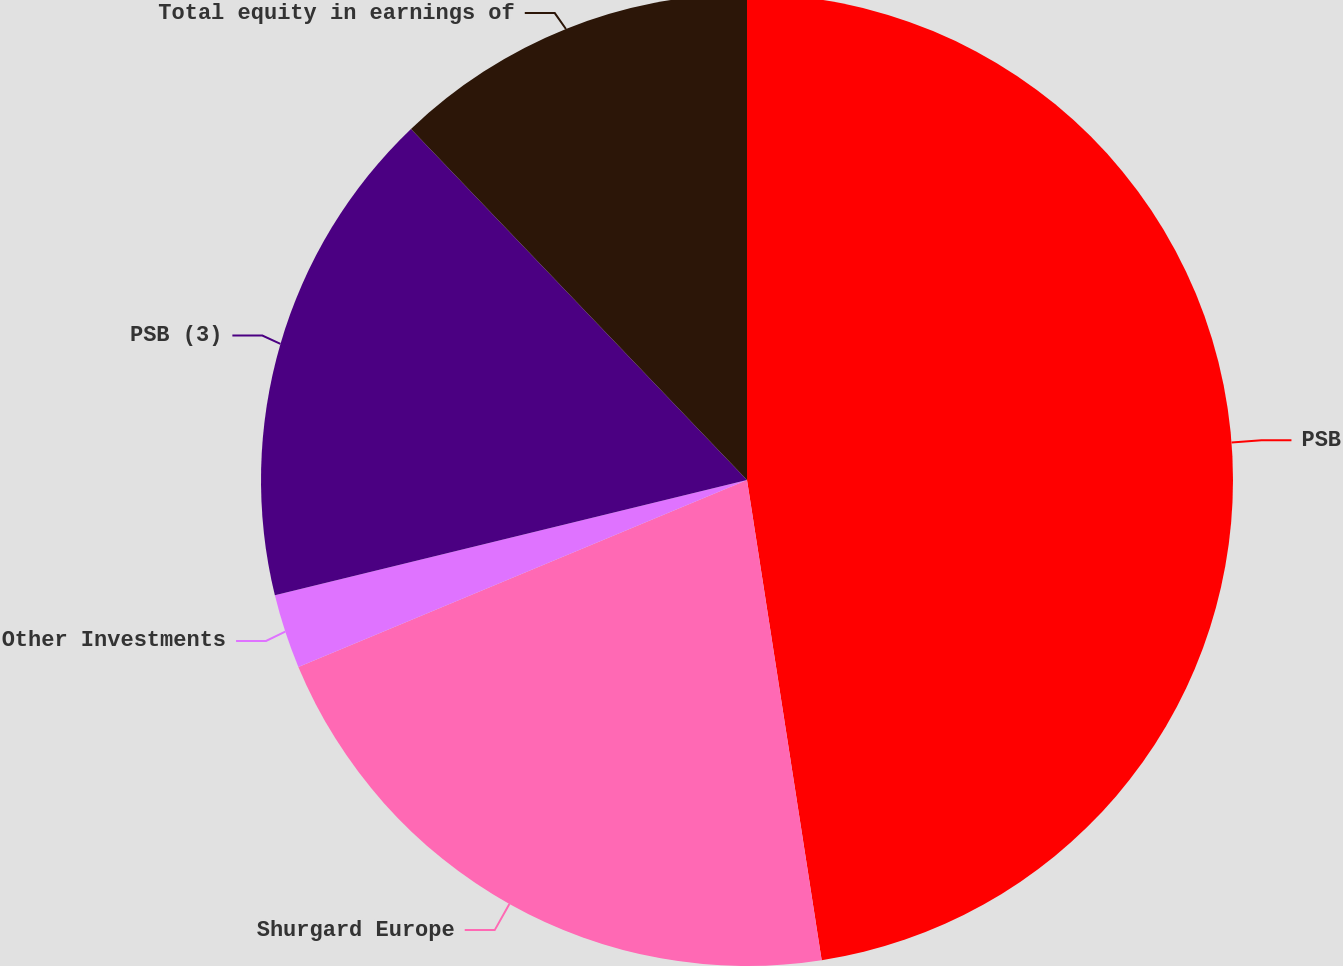Convert chart to OTSL. <chart><loc_0><loc_0><loc_500><loc_500><pie_chart><fcel>PSB<fcel>Shurgard Europe<fcel>Other Investments<fcel>PSB (3)<fcel>Total equity in earnings of<nl><fcel>47.54%<fcel>21.17%<fcel>2.47%<fcel>16.66%<fcel>12.15%<nl></chart> 